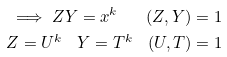<formula> <loc_0><loc_0><loc_500><loc_500>\implies Z Y = x ^ { k } \quad ( Z , Y ) = 1 \\ Z = U ^ { k } \quad Y = T ^ { k } \quad ( U , T ) = 1</formula> 